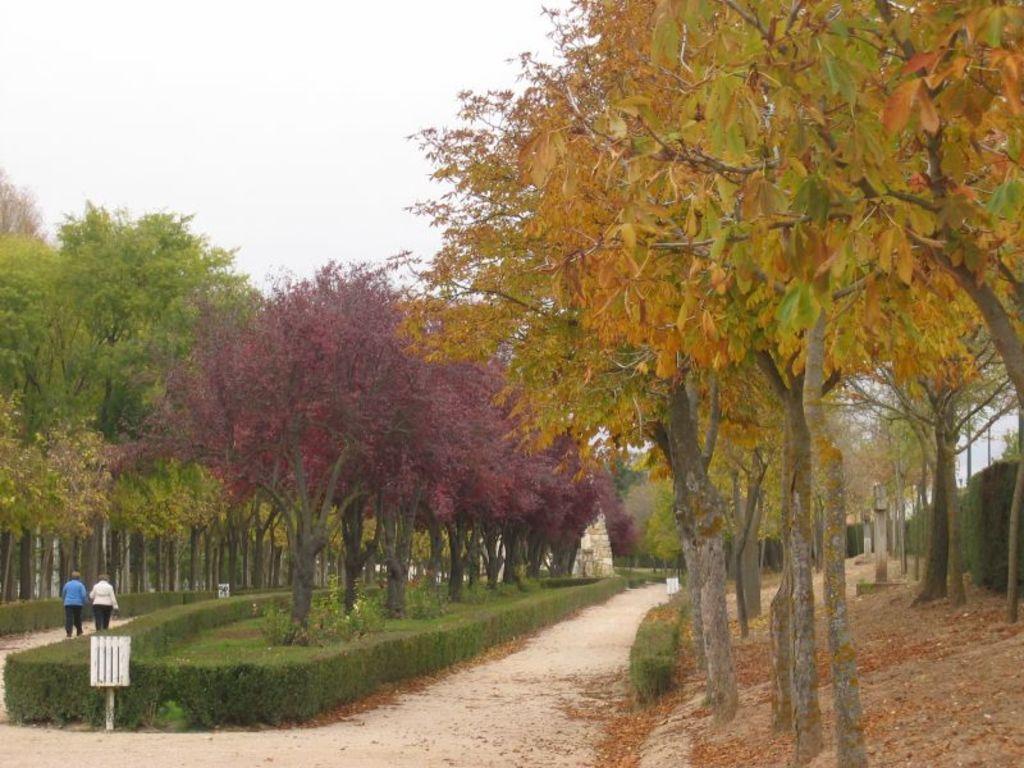Can you describe this image briefly? In this image there is the sky, there are trees, there are trees truncated towards the top of the image, there are trees truncated towards the right of the image, there are trees truncated towards the left of the image, there are plants, there are boards, there is a plant truncated towards the right of the image, there are two persons walking. 